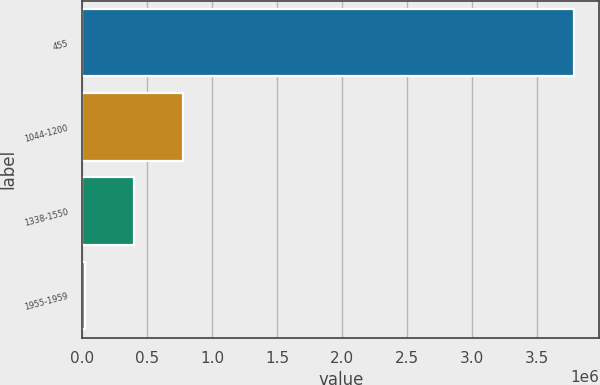Convert chart to OTSL. <chart><loc_0><loc_0><loc_500><loc_500><bar_chart><fcel>455<fcel>1044-1200<fcel>1338-1550<fcel>1955-1959<nl><fcel>3.79002e+06<fcel>774803<fcel>397902<fcel>21000<nl></chart> 